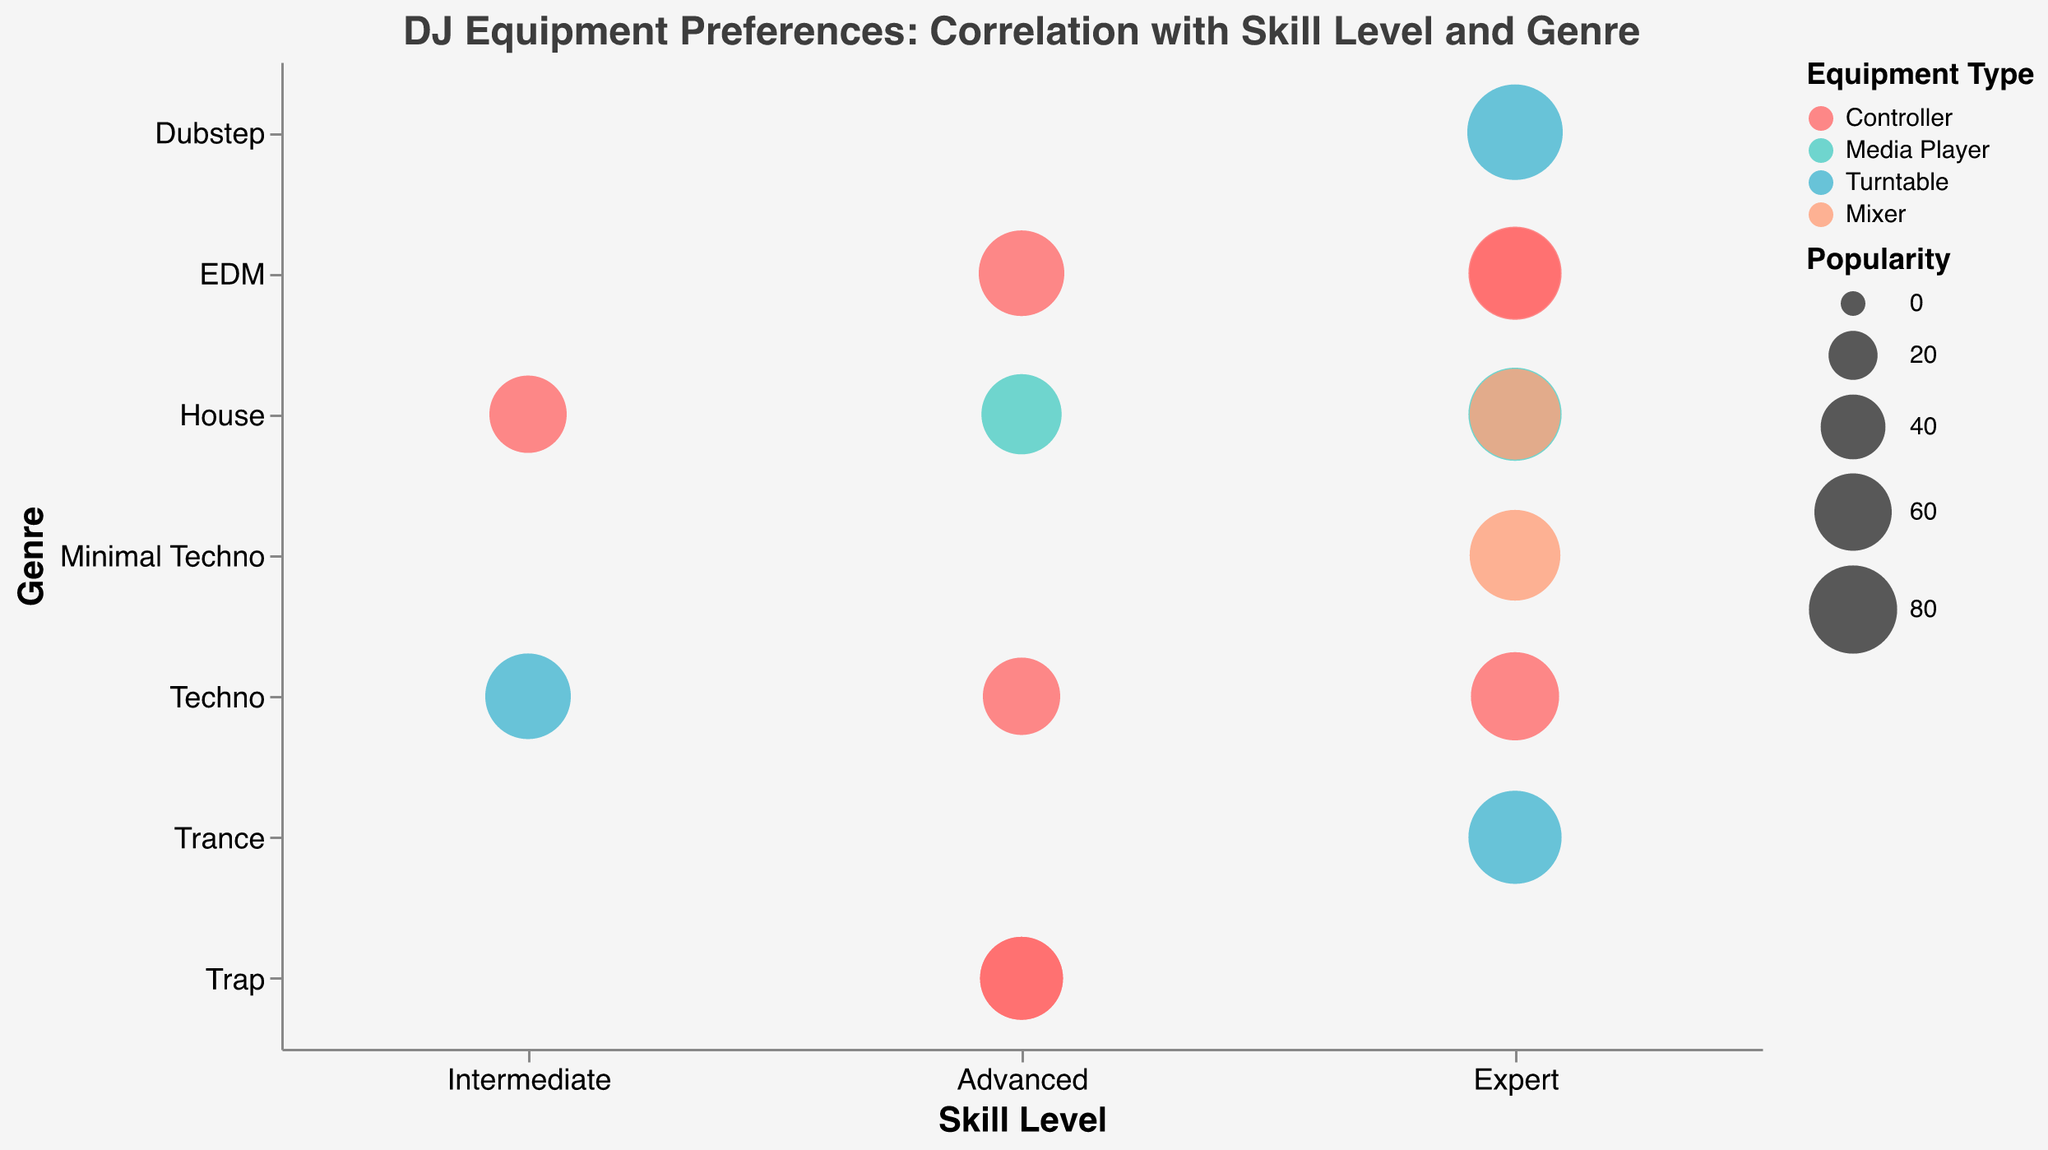What's the genre of DJs with the highest skill level and using turntables? The highest skill level is "Expert". Looking at DJs with this skill level using turntables, we have Carl Cox ("Techno"), Skrillex ("Dubstep"), and Armin van Buuren ("Trance"). Therefore, the genres are Techno, Dubstep, and Trance.
Answer: Techno, Dubstep, Trance Which DJ has the most popular equipment preference in the "House" genre? In the "House" genre, the DJs are David Guetta, Alesso, Tiësto, and Peggy Gou. David Guetta has a popularity of 90, Alesso has 65, Tiësto has 85, and Peggy Gou has 60. So, David Guetta has the most popular equipment preference in this genre.
Answer: David Guetta How many DJs prefer controllers? Looking at the "Equipment Type" legend and the data points, the DJs that use controllers are Alice Wonderland, Charlotte de Witte, Diplo, Martin Garrix, Nina Kraviz, DJ Snake, Zedd, and Peggy Gou. Counting these DJs gives a total of 8.
Answer: 8 What's the average popularity of DJs who are "Advanced" in skill level? The DJs with "Advanced" skill level are Diplo (70), Alesso (65), Nina Kraviz (60), DJ Snake (70), and Zedd (75). Sum these values: 70 + 65 + 60 + 70 + 75 = 340. The number of DJs is 5, so the average is 340 / 5 = 68.
Answer: 68 Who is the most popular DJ overall? Referring to the "Popularity" field, the highest popularity score is 95, which belongs to Skrillex.
Answer: Skrillex Do experts prefer any specific type of equipment more than others? Looking at the "Skill Level" of "Expert" and the "Equipment Type", we see that the experts use Controllers (Alice Wonderland, Charlotte de Witte, Martin Garrix), Media Players (David Guetta), Turntables (Skrillex, Armin van Buuren), and Mixers (Tiësto, Richie Hawtin). The number of users for each type is: Controllers = 3, Media Players = 1, Turntables = 2, Mixers = 2. Controllers are preferred slightly more among experts.
Answer: Controllers Is there any correlation between equipment type and genre among expert DJs? Examining the "Genre" and "Equipment Type" among expert DJs, we have the following: 
- EDM: Controllers (Alice Wonderland, Martin Garrix)
- House: Media Player (David Guetta), Mixer (Tiësto)
- Techno: Controller (Charlotte de Witte)
- Dubstep: Turntable (Skrillex)
- Trance: Turntable (Armin van Buuren)
- Minimal Techno: Mixer (Richie Hawtin)
 
Hence, experts use a variety of equipment types across different genres, with no strong correlation observed between specific equipment types and genres.
Answer: No strong correlation 